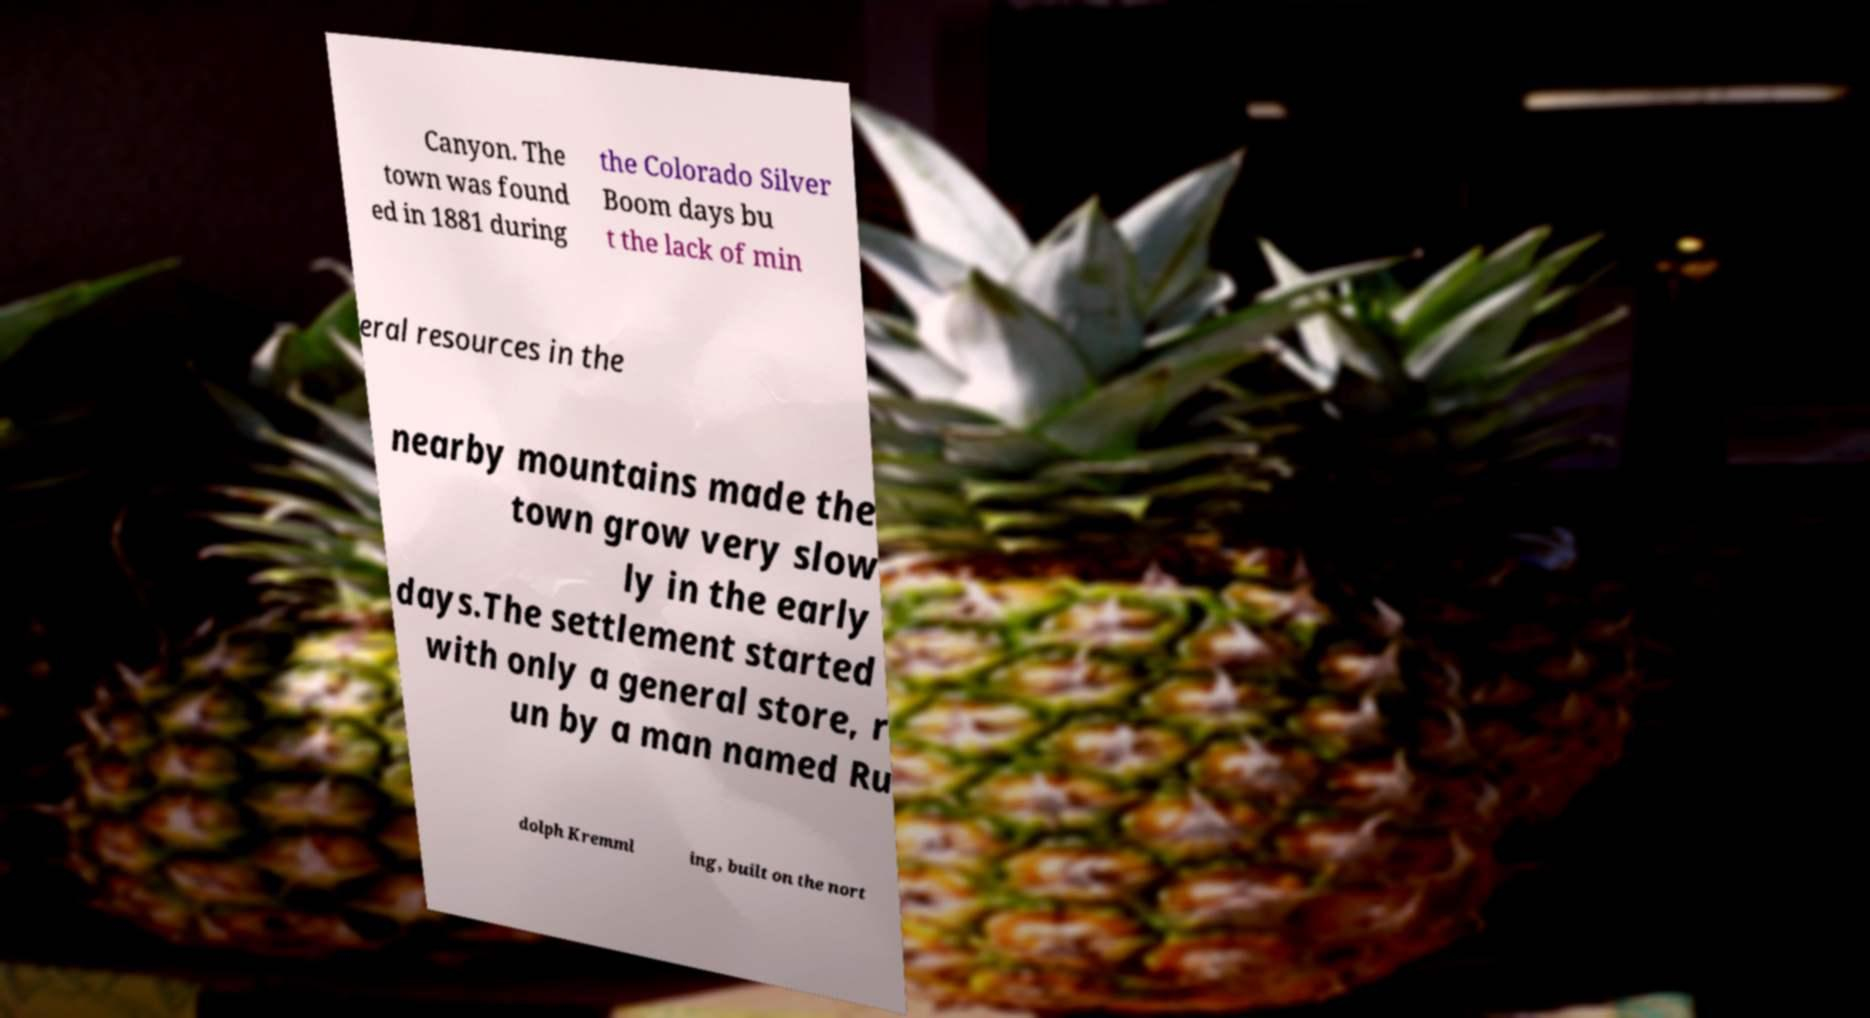I need the written content from this picture converted into text. Can you do that? Canyon. The town was found ed in 1881 during the Colorado Silver Boom days bu t the lack of min eral resources in the nearby mountains made the town grow very slow ly in the early days.The settlement started with only a general store, r un by a man named Ru dolph Kremml ing, built on the nort 